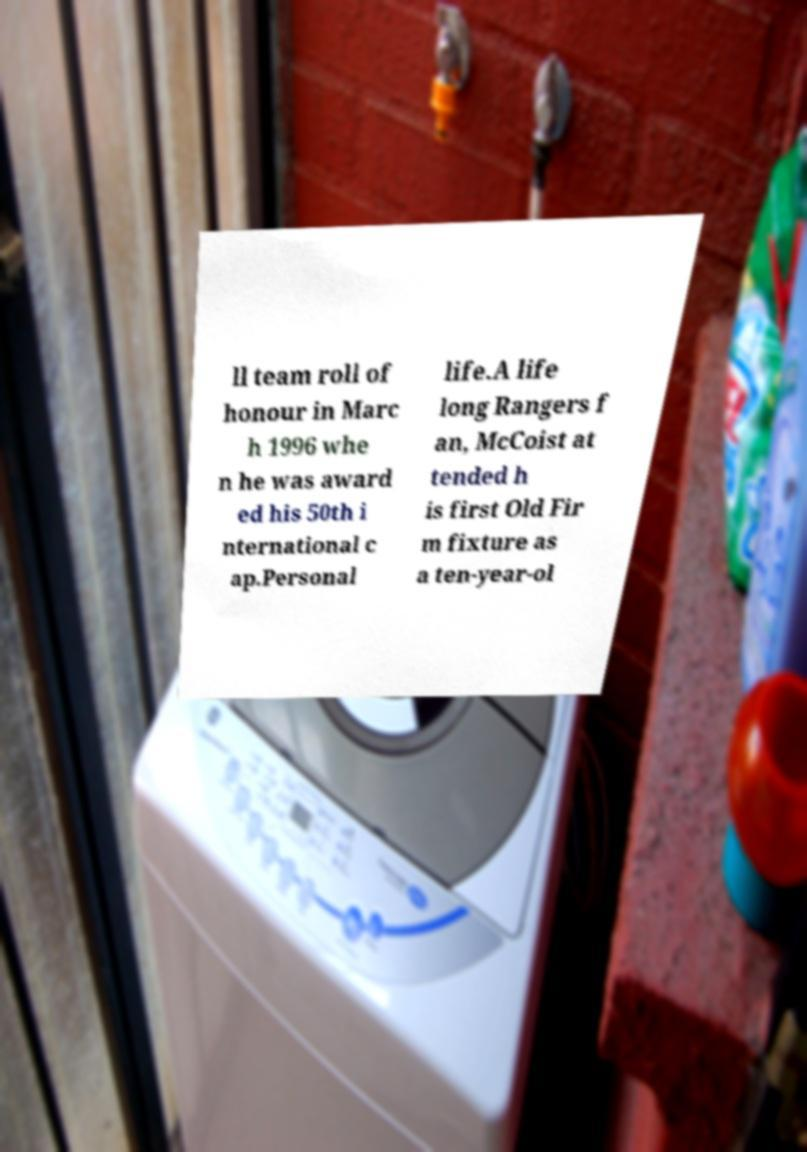Please read and relay the text visible in this image. What does it say? ll team roll of honour in Marc h 1996 whe n he was award ed his 50th i nternational c ap.Personal life.A life long Rangers f an, McCoist at tended h is first Old Fir m fixture as a ten-year-ol 